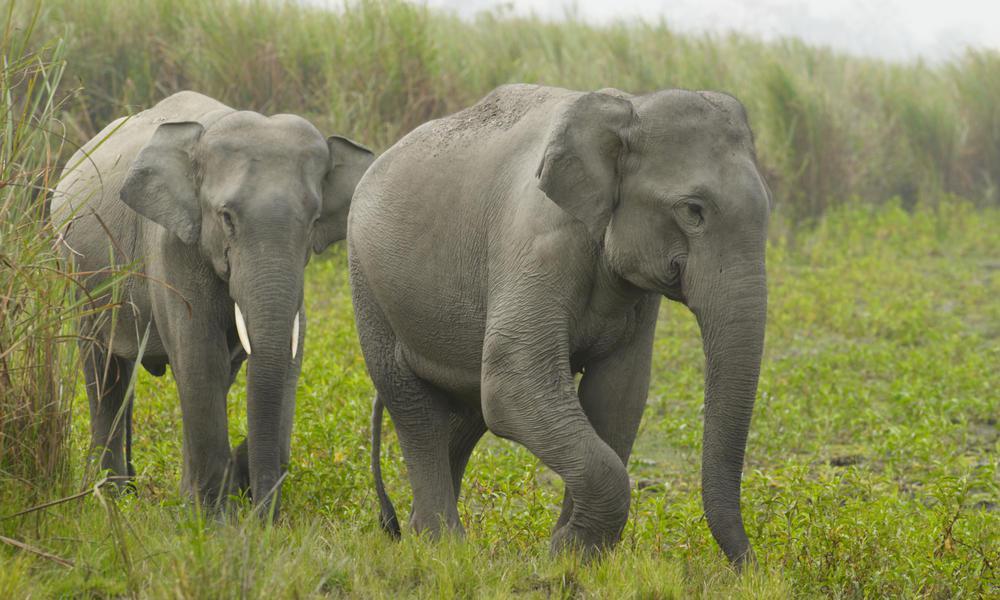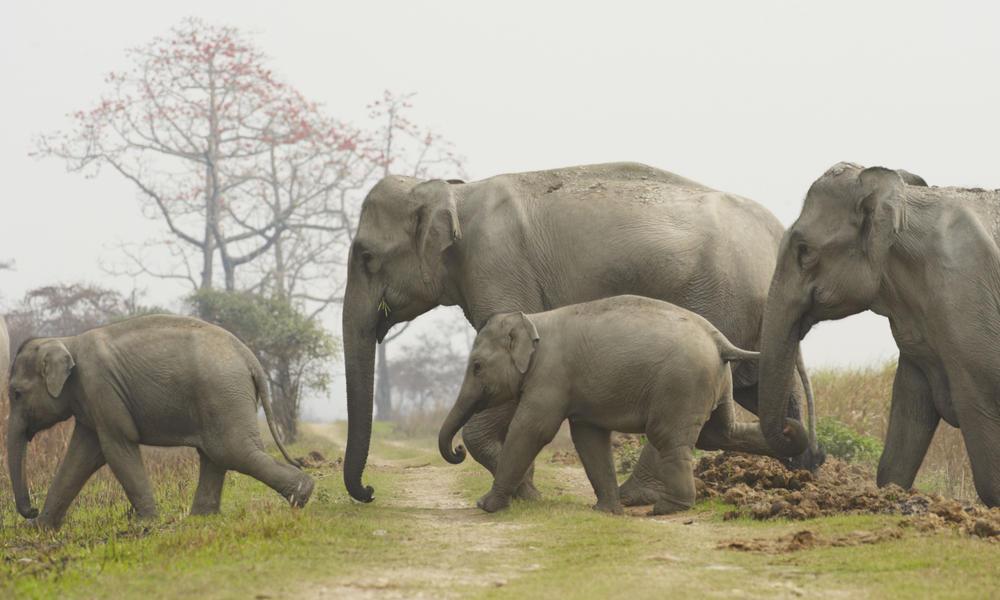The first image is the image on the left, the second image is the image on the right. For the images shown, is this caption "There are two elephants in total." true? Answer yes or no. No. 